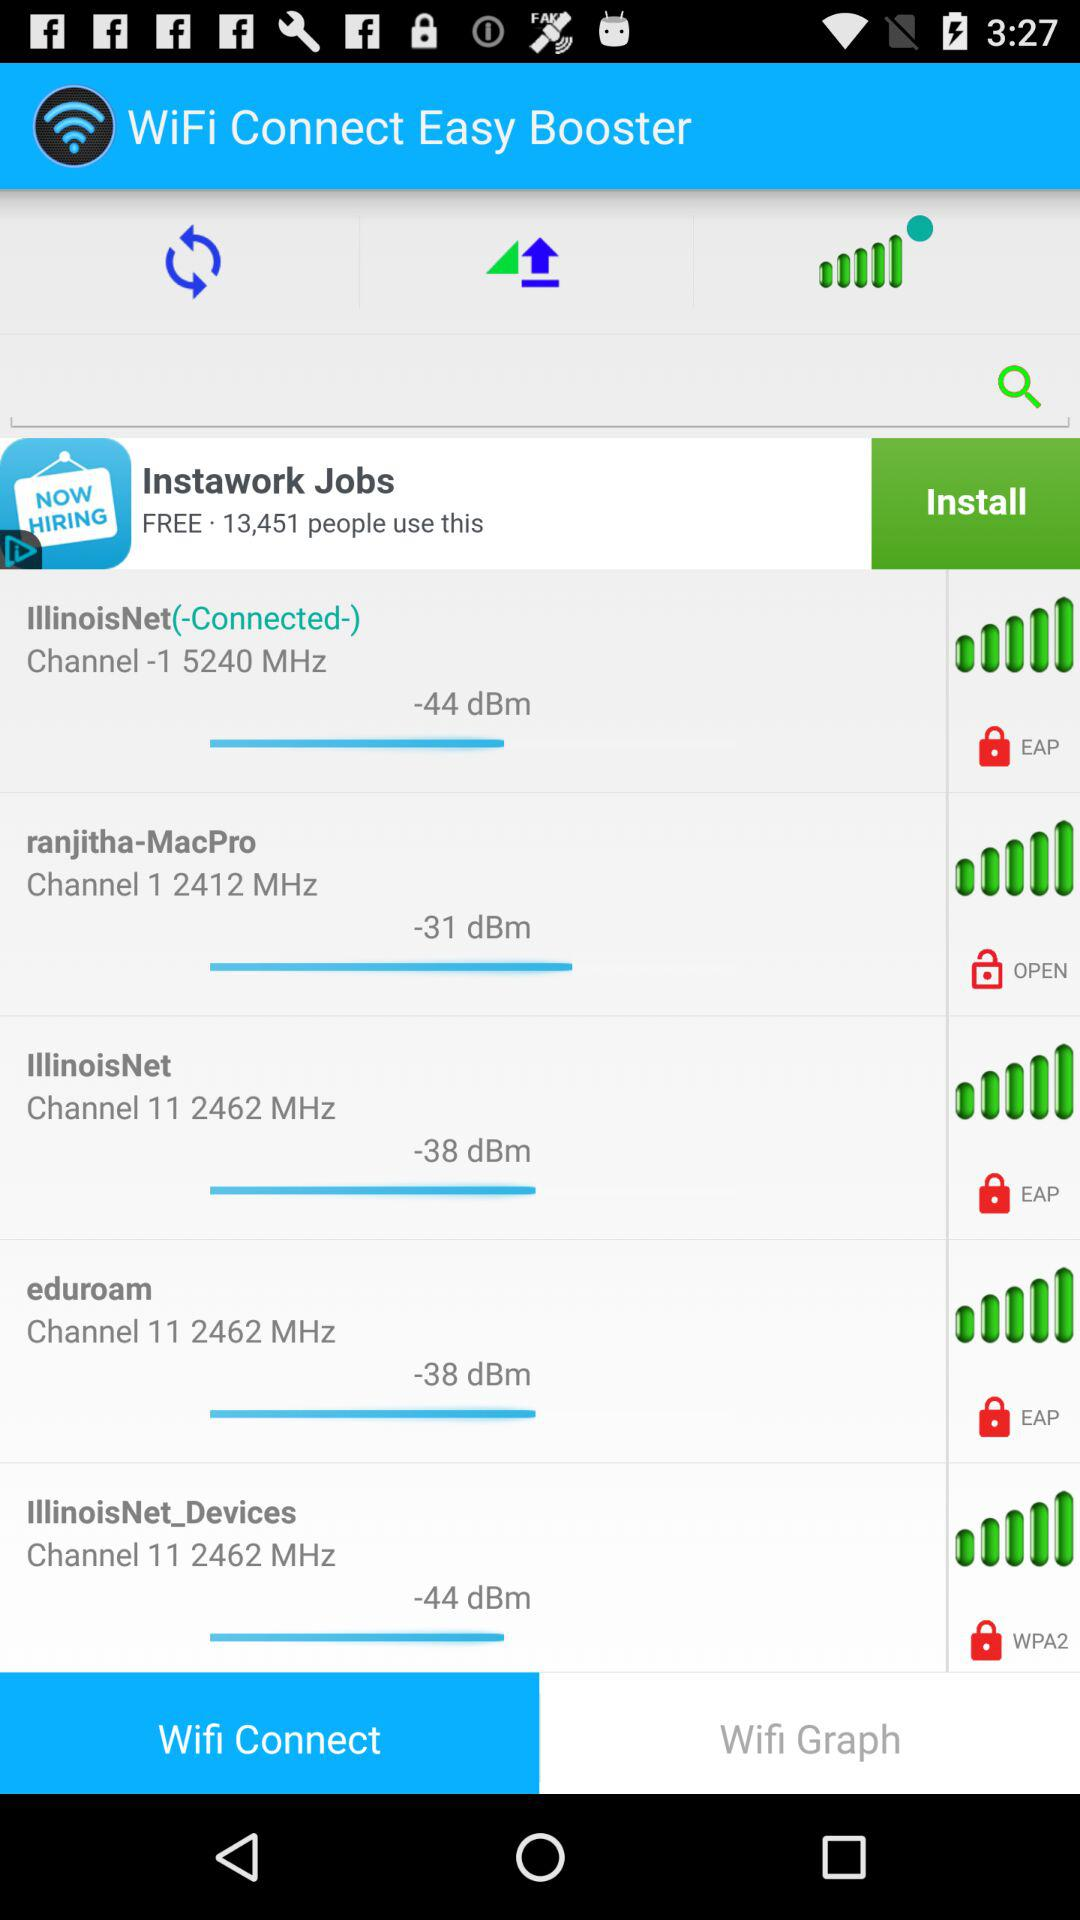Which wifi is open? The wifi that is open is "ranjitha-MacPro". 